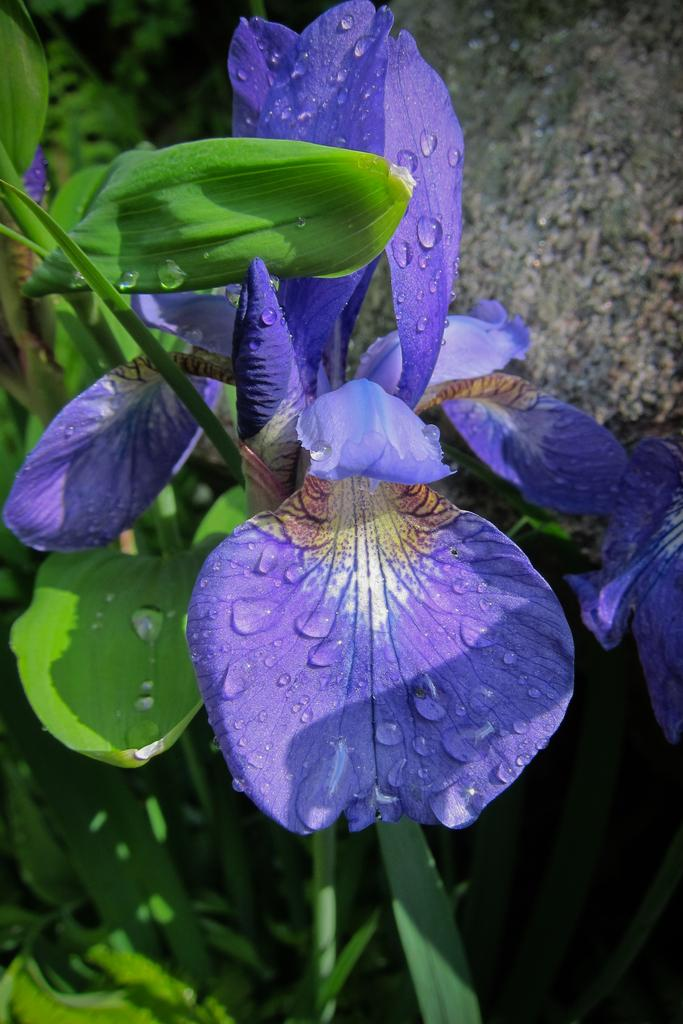What type of flowers can be seen in the image? There are purple color flowers in the image. What else is present in the image besides the flowers? There are leaves in the image. Can you describe the background of the image? The background of the image is blurry. What type of profit can be seen in the image? There is no mention of profit in the image; it features flowers and leaves. What effect does the image have on the viewer? The image's effect on the viewer cannot be determined from the provided facts. 